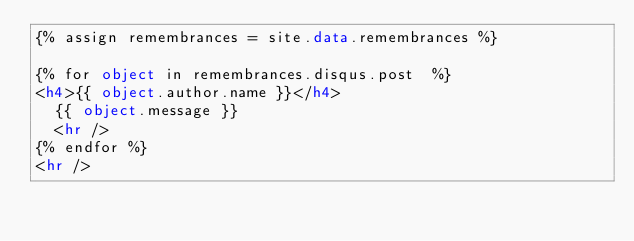<code> <loc_0><loc_0><loc_500><loc_500><_HTML_>{% assign remembrances = site.data.remembrances %}

{% for object in remembrances.disqus.post  %}
<h4>{{ object.author.name }}</h4>
  {{ object.message }}
  <hr />
{% endfor %}
<hr />
</code> 